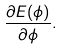<formula> <loc_0><loc_0><loc_500><loc_500>\frac { \partial E ( \phi ) } { \partial \phi } .</formula> 